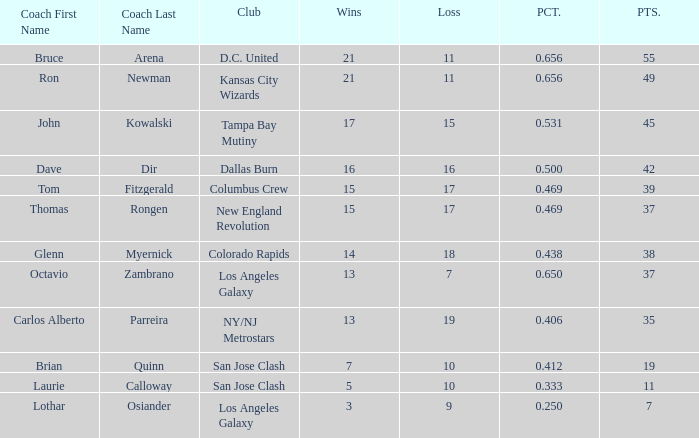What is the sum of points when Bruce Arena has 21 wins? 55.0. 